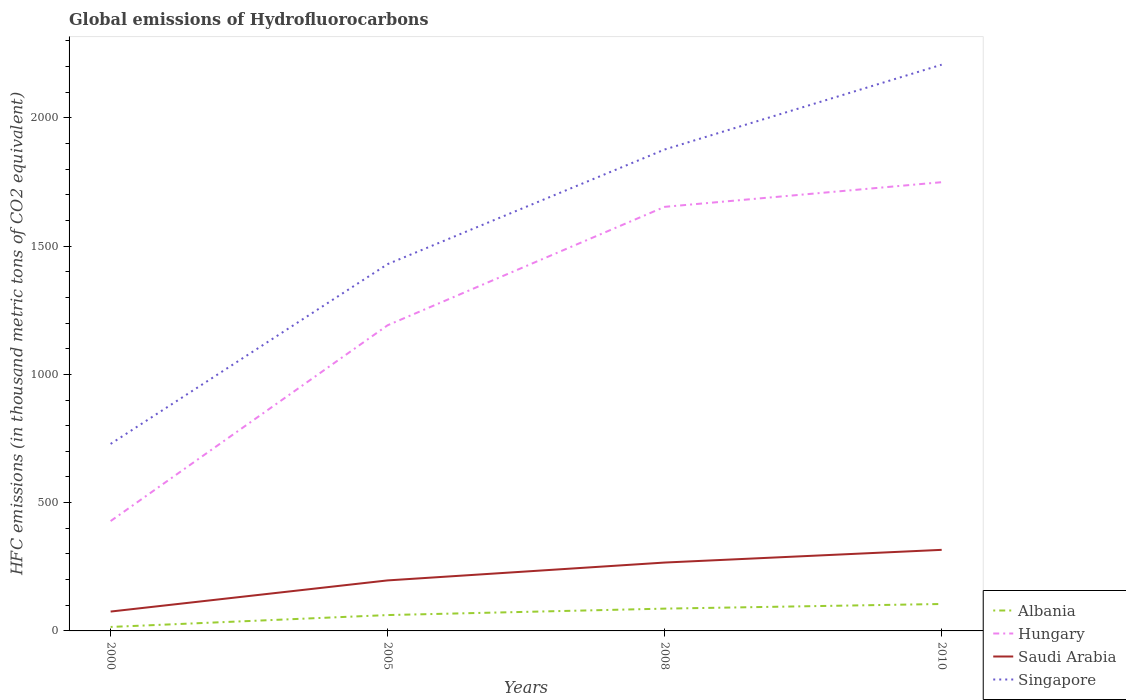Across all years, what is the maximum global emissions of Hydrofluorocarbons in Saudi Arabia?
Your response must be concise. 75.5. In which year was the global emissions of Hydrofluorocarbons in Hungary maximum?
Your answer should be very brief. 2000. What is the total global emissions of Hydrofluorocarbons in Saudi Arabia in the graph?
Provide a succinct answer. -49.5. What is the difference between the highest and the second highest global emissions of Hydrofluorocarbons in Albania?
Your response must be concise. 89.5. Is the global emissions of Hydrofluorocarbons in Hungary strictly greater than the global emissions of Hydrofluorocarbons in Saudi Arabia over the years?
Provide a short and direct response. No. How many years are there in the graph?
Your response must be concise. 4. Does the graph contain grids?
Give a very brief answer. No. How many legend labels are there?
Your response must be concise. 4. What is the title of the graph?
Your answer should be compact. Global emissions of Hydrofluorocarbons. Does "Botswana" appear as one of the legend labels in the graph?
Offer a very short reply. No. What is the label or title of the X-axis?
Provide a succinct answer. Years. What is the label or title of the Y-axis?
Make the answer very short. HFC emissions (in thousand metric tons of CO2 equivalent). What is the HFC emissions (in thousand metric tons of CO2 equivalent) of Hungary in 2000?
Offer a terse response. 428.2. What is the HFC emissions (in thousand metric tons of CO2 equivalent) of Saudi Arabia in 2000?
Offer a terse response. 75.5. What is the HFC emissions (in thousand metric tons of CO2 equivalent) of Singapore in 2000?
Provide a short and direct response. 728.9. What is the HFC emissions (in thousand metric tons of CO2 equivalent) in Albania in 2005?
Your answer should be compact. 61.8. What is the HFC emissions (in thousand metric tons of CO2 equivalent) in Hungary in 2005?
Provide a succinct answer. 1191.4. What is the HFC emissions (in thousand metric tons of CO2 equivalent) of Saudi Arabia in 2005?
Your answer should be compact. 196.9. What is the HFC emissions (in thousand metric tons of CO2 equivalent) in Singapore in 2005?
Offer a terse response. 1429.7. What is the HFC emissions (in thousand metric tons of CO2 equivalent) in Albania in 2008?
Provide a succinct answer. 86.9. What is the HFC emissions (in thousand metric tons of CO2 equivalent) of Hungary in 2008?
Keep it short and to the point. 1652.9. What is the HFC emissions (in thousand metric tons of CO2 equivalent) in Saudi Arabia in 2008?
Your response must be concise. 266.5. What is the HFC emissions (in thousand metric tons of CO2 equivalent) in Singapore in 2008?
Your answer should be compact. 1876.4. What is the HFC emissions (in thousand metric tons of CO2 equivalent) of Albania in 2010?
Your answer should be compact. 105. What is the HFC emissions (in thousand metric tons of CO2 equivalent) of Hungary in 2010?
Provide a succinct answer. 1749. What is the HFC emissions (in thousand metric tons of CO2 equivalent) of Saudi Arabia in 2010?
Provide a succinct answer. 316. What is the HFC emissions (in thousand metric tons of CO2 equivalent) in Singapore in 2010?
Ensure brevity in your answer.  2207. Across all years, what is the maximum HFC emissions (in thousand metric tons of CO2 equivalent) of Albania?
Offer a very short reply. 105. Across all years, what is the maximum HFC emissions (in thousand metric tons of CO2 equivalent) in Hungary?
Your answer should be very brief. 1749. Across all years, what is the maximum HFC emissions (in thousand metric tons of CO2 equivalent) of Saudi Arabia?
Your answer should be very brief. 316. Across all years, what is the maximum HFC emissions (in thousand metric tons of CO2 equivalent) of Singapore?
Make the answer very short. 2207. Across all years, what is the minimum HFC emissions (in thousand metric tons of CO2 equivalent) of Hungary?
Provide a short and direct response. 428.2. Across all years, what is the minimum HFC emissions (in thousand metric tons of CO2 equivalent) of Saudi Arabia?
Give a very brief answer. 75.5. Across all years, what is the minimum HFC emissions (in thousand metric tons of CO2 equivalent) of Singapore?
Give a very brief answer. 728.9. What is the total HFC emissions (in thousand metric tons of CO2 equivalent) in Albania in the graph?
Provide a short and direct response. 269.2. What is the total HFC emissions (in thousand metric tons of CO2 equivalent) in Hungary in the graph?
Make the answer very short. 5021.5. What is the total HFC emissions (in thousand metric tons of CO2 equivalent) of Saudi Arabia in the graph?
Offer a terse response. 854.9. What is the total HFC emissions (in thousand metric tons of CO2 equivalent) in Singapore in the graph?
Your answer should be compact. 6242. What is the difference between the HFC emissions (in thousand metric tons of CO2 equivalent) in Albania in 2000 and that in 2005?
Your answer should be compact. -46.3. What is the difference between the HFC emissions (in thousand metric tons of CO2 equivalent) of Hungary in 2000 and that in 2005?
Ensure brevity in your answer.  -763.2. What is the difference between the HFC emissions (in thousand metric tons of CO2 equivalent) of Saudi Arabia in 2000 and that in 2005?
Give a very brief answer. -121.4. What is the difference between the HFC emissions (in thousand metric tons of CO2 equivalent) in Singapore in 2000 and that in 2005?
Provide a short and direct response. -700.8. What is the difference between the HFC emissions (in thousand metric tons of CO2 equivalent) of Albania in 2000 and that in 2008?
Provide a succinct answer. -71.4. What is the difference between the HFC emissions (in thousand metric tons of CO2 equivalent) of Hungary in 2000 and that in 2008?
Give a very brief answer. -1224.7. What is the difference between the HFC emissions (in thousand metric tons of CO2 equivalent) of Saudi Arabia in 2000 and that in 2008?
Give a very brief answer. -191. What is the difference between the HFC emissions (in thousand metric tons of CO2 equivalent) of Singapore in 2000 and that in 2008?
Give a very brief answer. -1147.5. What is the difference between the HFC emissions (in thousand metric tons of CO2 equivalent) in Albania in 2000 and that in 2010?
Ensure brevity in your answer.  -89.5. What is the difference between the HFC emissions (in thousand metric tons of CO2 equivalent) of Hungary in 2000 and that in 2010?
Provide a succinct answer. -1320.8. What is the difference between the HFC emissions (in thousand metric tons of CO2 equivalent) of Saudi Arabia in 2000 and that in 2010?
Provide a short and direct response. -240.5. What is the difference between the HFC emissions (in thousand metric tons of CO2 equivalent) of Singapore in 2000 and that in 2010?
Provide a short and direct response. -1478.1. What is the difference between the HFC emissions (in thousand metric tons of CO2 equivalent) of Albania in 2005 and that in 2008?
Make the answer very short. -25.1. What is the difference between the HFC emissions (in thousand metric tons of CO2 equivalent) in Hungary in 2005 and that in 2008?
Provide a short and direct response. -461.5. What is the difference between the HFC emissions (in thousand metric tons of CO2 equivalent) in Saudi Arabia in 2005 and that in 2008?
Your answer should be very brief. -69.6. What is the difference between the HFC emissions (in thousand metric tons of CO2 equivalent) of Singapore in 2005 and that in 2008?
Keep it short and to the point. -446.7. What is the difference between the HFC emissions (in thousand metric tons of CO2 equivalent) in Albania in 2005 and that in 2010?
Make the answer very short. -43.2. What is the difference between the HFC emissions (in thousand metric tons of CO2 equivalent) of Hungary in 2005 and that in 2010?
Ensure brevity in your answer.  -557.6. What is the difference between the HFC emissions (in thousand metric tons of CO2 equivalent) of Saudi Arabia in 2005 and that in 2010?
Make the answer very short. -119.1. What is the difference between the HFC emissions (in thousand metric tons of CO2 equivalent) in Singapore in 2005 and that in 2010?
Provide a short and direct response. -777.3. What is the difference between the HFC emissions (in thousand metric tons of CO2 equivalent) of Albania in 2008 and that in 2010?
Your answer should be compact. -18.1. What is the difference between the HFC emissions (in thousand metric tons of CO2 equivalent) in Hungary in 2008 and that in 2010?
Offer a terse response. -96.1. What is the difference between the HFC emissions (in thousand metric tons of CO2 equivalent) in Saudi Arabia in 2008 and that in 2010?
Provide a succinct answer. -49.5. What is the difference between the HFC emissions (in thousand metric tons of CO2 equivalent) in Singapore in 2008 and that in 2010?
Give a very brief answer. -330.6. What is the difference between the HFC emissions (in thousand metric tons of CO2 equivalent) in Albania in 2000 and the HFC emissions (in thousand metric tons of CO2 equivalent) in Hungary in 2005?
Provide a short and direct response. -1175.9. What is the difference between the HFC emissions (in thousand metric tons of CO2 equivalent) of Albania in 2000 and the HFC emissions (in thousand metric tons of CO2 equivalent) of Saudi Arabia in 2005?
Provide a short and direct response. -181.4. What is the difference between the HFC emissions (in thousand metric tons of CO2 equivalent) of Albania in 2000 and the HFC emissions (in thousand metric tons of CO2 equivalent) of Singapore in 2005?
Provide a short and direct response. -1414.2. What is the difference between the HFC emissions (in thousand metric tons of CO2 equivalent) in Hungary in 2000 and the HFC emissions (in thousand metric tons of CO2 equivalent) in Saudi Arabia in 2005?
Keep it short and to the point. 231.3. What is the difference between the HFC emissions (in thousand metric tons of CO2 equivalent) of Hungary in 2000 and the HFC emissions (in thousand metric tons of CO2 equivalent) of Singapore in 2005?
Your answer should be compact. -1001.5. What is the difference between the HFC emissions (in thousand metric tons of CO2 equivalent) in Saudi Arabia in 2000 and the HFC emissions (in thousand metric tons of CO2 equivalent) in Singapore in 2005?
Give a very brief answer. -1354.2. What is the difference between the HFC emissions (in thousand metric tons of CO2 equivalent) in Albania in 2000 and the HFC emissions (in thousand metric tons of CO2 equivalent) in Hungary in 2008?
Make the answer very short. -1637.4. What is the difference between the HFC emissions (in thousand metric tons of CO2 equivalent) in Albania in 2000 and the HFC emissions (in thousand metric tons of CO2 equivalent) in Saudi Arabia in 2008?
Offer a terse response. -251. What is the difference between the HFC emissions (in thousand metric tons of CO2 equivalent) of Albania in 2000 and the HFC emissions (in thousand metric tons of CO2 equivalent) of Singapore in 2008?
Give a very brief answer. -1860.9. What is the difference between the HFC emissions (in thousand metric tons of CO2 equivalent) of Hungary in 2000 and the HFC emissions (in thousand metric tons of CO2 equivalent) of Saudi Arabia in 2008?
Provide a succinct answer. 161.7. What is the difference between the HFC emissions (in thousand metric tons of CO2 equivalent) of Hungary in 2000 and the HFC emissions (in thousand metric tons of CO2 equivalent) of Singapore in 2008?
Offer a very short reply. -1448.2. What is the difference between the HFC emissions (in thousand metric tons of CO2 equivalent) of Saudi Arabia in 2000 and the HFC emissions (in thousand metric tons of CO2 equivalent) of Singapore in 2008?
Give a very brief answer. -1800.9. What is the difference between the HFC emissions (in thousand metric tons of CO2 equivalent) in Albania in 2000 and the HFC emissions (in thousand metric tons of CO2 equivalent) in Hungary in 2010?
Ensure brevity in your answer.  -1733.5. What is the difference between the HFC emissions (in thousand metric tons of CO2 equivalent) of Albania in 2000 and the HFC emissions (in thousand metric tons of CO2 equivalent) of Saudi Arabia in 2010?
Provide a succinct answer. -300.5. What is the difference between the HFC emissions (in thousand metric tons of CO2 equivalent) of Albania in 2000 and the HFC emissions (in thousand metric tons of CO2 equivalent) of Singapore in 2010?
Ensure brevity in your answer.  -2191.5. What is the difference between the HFC emissions (in thousand metric tons of CO2 equivalent) of Hungary in 2000 and the HFC emissions (in thousand metric tons of CO2 equivalent) of Saudi Arabia in 2010?
Provide a short and direct response. 112.2. What is the difference between the HFC emissions (in thousand metric tons of CO2 equivalent) of Hungary in 2000 and the HFC emissions (in thousand metric tons of CO2 equivalent) of Singapore in 2010?
Offer a very short reply. -1778.8. What is the difference between the HFC emissions (in thousand metric tons of CO2 equivalent) of Saudi Arabia in 2000 and the HFC emissions (in thousand metric tons of CO2 equivalent) of Singapore in 2010?
Your answer should be very brief. -2131.5. What is the difference between the HFC emissions (in thousand metric tons of CO2 equivalent) of Albania in 2005 and the HFC emissions (in thousand metric tons of CO2 equivalent) of Hungary in 2008?
Offer a terse response. -1591.1. What is the difference between the HFC emissions (in thousand metric tons of CO2 equivalent) in Albania in 2005 and the HFC emissions (in thousand metric tons of CO2 equivalent) in Saudi Arabia in 2008?
Your answer should be very brief. -204.7. What is the difference between the HFC emissions (in thousand metric tons of CO2 equivalent) in Albania in 2005 and the HFC emissions (in thousand metric tons of CO2 equivalent) in Singapore in 2008?
Provide a short and direct response. -1814.6. What is the difference between the HFC emissions (in thousand metric tons of CO2 equivalent) in Hungary in 2005 and the HFC emissions (in thousand metric tons of CO2 equivalent) in Saudi Arabia in 2008?
Make the answer very short. 924.9. What is the difference between the HFC emissions (in thousand metric tons of CO2 equivalent) of Hungary in 2005 and the HFC emissions (in thousand metric tons of CO2 equivalent) of Singapore in 2008?
Provide a short and direct response. -685. What is the difference between the HFC emissions (in thousand metric tons of CO2 equivalent) of Saudi Arabia in 2005 and the HFC emissions (in thousand metric tons of CO2 equivalent) of Singapore in 2008?
Your answer should be very brief. -1679.5. What is the difference between the HFC emissions (in thousand metric tons of CO2 equivalent) in Albania in 2005 and the HFC emissions (in thousand metric tons of CO2 equivalent) in Hungary in 2010?
Your response must be concise. -1687.2. What is the difference between the HFC emissions (in thousand metric tons of CO2 equivalent) in Albania in 2005 and the HFC emissions (in thousand metric tons of CO2 equivalent) in Saudi Arabia in 2010?
Your answer should be compact. -254.2. What is the difference between the HFC emissions (in thousand metric tons of CO2 equivalent) of Albania in 2005 and the HFC emissions (in thousand metric tons of CO2 equivalent) of Singapore in 2010?
Keep it short and to the point. -2145.2. What is the difference between the HFC emissions (in thousand metric tons of CO2 equivalent) of Hungary in 2005 and the HFC emissions (in thousand metric tons of CO2 equivalent) of Saudi Arabia in 2010?
Give a very brief answer. 875.4. What is the difference between the HFC emissions (in thousand metric tons of CO2 equivalent) in Hungary in 2005 and the HFC emissions (in thousand metric tons of CO2 equivalent) in Singapore in 2010?
Provide a short and direct response. -1015.6. What is the difference between the HFC emissions (in thousand metric tons of CO2 equivalent) in Saudi Arabia in 2005 and the HFC emissions (in thousand metric tons of CO2 equivalent) in Singapore in 2010?
Provide a succinct answer. -2010.1. What is the difference between the HFC emissions (in thousand metric tons of CO2 equivalent) of Albania in 2008 and the HFC emissions (in thousand metric tons of CO2 equivalent) of Hungary in 2010?
Your response must be concise. -1662.1. What is the difference between the HFC emissions (in thousand metric tons of CO2 equivalent) in Albania in 2008 and the HFC emissions (in thousand metric tons of CO2 equivalent) in Saudi Arabia in 2010?
Offer a very short reply. -229.1. What is the difference between the HFC emissions (in thousand metric tons of CO2 equivalent) of Albania in 2008 and the HFC emissions (in thousand metric tons of CO2 equivalent) of Singapore in 2010?
Your response must be concise. -2120.1. What is the difference between the HFC emissions (in thousand metric tons of CO2 equivalent) in Hungary in 2008 and the HFC emissions (in thousand metric tons of CO2 equivalent) in Saudi Arabia in 2010?
Keep it short and to the point. 1336.9. What is the difference between the HFC emissions (in thousand metric tons of CO2 equivalent) of Hungary in 2008 and the HFC emissions (in thousand metric tons of CO2 equivalent) of Singapore in 2010?
Keep it short and to the point. -554.1. What is the difference between the HFC emissions (in thousand metric tons of CO2 equivalent) in Saudi Arabia in 2008 and the HFC emissions (in thousand metric tons of CO2 equivalent) in Singapore in 2010?
Your answer should be compact. -1940.5. What is the average HFC emissions (in thousand metric tons of CO2 equivalent) of Albania per year?
Ensure brevity in your answer.  67.3. What is the average HFC emissions (in thousand metric tons of CO2 equivalent) of Hungary per year?
Your response must be concise. 1255.38. What is the average HFC emissions (in thousand metric tons of CO2 equivalent) of Saudi Arabia per year?
Offer a terse response. 213.72. What is the average HFC emissions (in thousand metric tons of CO2 equivalent) in Singapore per year?
Provide a succinct answer. 1560.5. In the year 2000, what is the difference between the HFC emissions (in thousand metric tons of CO2 equivalent) of Albania and HFC emissions (in thousand metric tons of CO2 equivalent) of Hungary?
Give a very brief answer. -412.7. In the year 2000, what is the difference between the HFC emissions (in thousand metric tons of CO2 equivalent) of Albania and HFC emissions (in thousand metric tons of CO2 equivalent) of Saudi Arabia?
Give a very brief answer. -60. In the year 2000, what is the difference between the HFC emissions (in thousand metric tons of CO2 equivalent) of Albania and HFC emissions (in thousand metric tons of CO2 equivalent) of Singapore?
Your answer should be compact. -713.4. In the year 2000, what is the difference between the HFC emissions (in thousand metric tons of CO2 equivalent) of Hungary and HFC emissions (in thousand metric tons of CO2 equivalent) of Saudi Arabia?
Provide a short and direct response. 352.7. In the year 2000, what is the difference between the HFC emissions (in thousand metric tons of CO2 equivalent) in Hungary and HFC emissions (in thousand metric tons of CO2 equivalent) in Singapore?
Your answer should be compact. -300.7. In the year 2000, what is the difference between the HFC emissions (in thousand metric tons of CO2 equivalent) in Saudi Arabia and HFC emissions (in thousand metric tons of CO2 equivalent) in Singapore?
Provide a short and direct response. -653.4. In the year 2005, what is the difference between the HFC emissions (in thousand metric tons of CO2 equivalent) of Albania and HFC emissions (in thousand metric tons of CO2 equivalent) of Hungary?
Provide a short and direct response. -1129.6. In the year 2005, what is the difference between the HFC emissions (in thousand metric tons of CO2 equivalent) of Albania and HFC emissions (in thousand metric tons of CO2 equivalent) of Saudi Arabia?
Offer a very short reply. -135.1. In the year 2005, what is the difference between the HFC emissions (in thousand metric tons of CO2 equivalent) of Albania and HFC emissions (in thousand metric tons of CO2 equivalent) of Singapore?
Make the answer very short. -1367.9. In the year 2005, what is the difference between the HFC emissions (in thousand metric tons of CO2 equivalent) of Hungary and HFC emissions (in thousand metric tons of CO2 equivalent) of Saudi Arabia?
Ensure brevity in your answer.  994.5. In the year 2005, what is the difference between the HFC emissions (in thousand metric tons of CO2 equivalent) in Hungary and HFC emissions (in thousand metric tons of CO2 equivalent) in Singapore?
Offer a very short reply. -238.3. In the year 2005, what is the difference between the HFC emissions (in thousand metric tons of CO2 equivalent) in Saudi Arabia and HFC emissions (in thousand metric tons of CO2 equivalent) in Singapore?
Give a very brief answer. -1232.8. In the year 2008, what is the difference between the HFC emissions (in thousand metric tons of CO2 equivalent) of Albania and HFC emissions (in thousand metric tons of CO2 equivalent) of Hungary?
Provide a short and direct response. -1566. In the year 2008, what is the difference between the HFC emissions (in thousand metric tons of CO2 equivalent) in Albania and HFC emissions (in thousand metric tons of CO2 equivalent) in Saudi Arabia?
Your answer should be compact. -179.6. In the year 2008, what is the difference between the HFC emissions (in thousand metric tons of CO2 equivalent) in Albania and HFC emissions (in thousand metric tons of CO2 equivalent) in Singapore?
Your response must be concise. -1789.5. In the year 2008, what is the difference between the HFC emissions (in thousand metric tons of CO2 equivalent) of Hungary and HFC emissions (in thousand metric tons of CO2 equivalent) of Saudi Arabia?
Keep it short and to the point. 1386.4. In the year 2008, what is the difference between the HFC emissions (in thousand metric tons of CO2 equivalent) in Hungary and HFC emissions (in thousand metric tons of CO2 equivalent) in Singapore?
Your response must be concise. -223.5. In the year 2008, what is the difference between the HFC emissions (in thousand metric tons of CO2 equivalent) of Saudi Arabia and HFC emissions (in thousand metric tons of CO2 equivalent) of Singapore?
Your response must be concise. -1609.9. In the year 2010, what is the difference between the HFC emissions (in thousand metric tons of CO2 equivalent) of Albania and HFC emissions (in thousand metric tons of CO2 equivalent) of Hungary?
Provide a short and direct response. -1644. In the year 2010, what is the difference between the HFC emissions (in thousand metric tons of CO2 equivalent) of Albania and HFC emissions (in thousand metric tons of CO2 equivalent) of Saudi Arabia?
Ensure brevity in your answer.  -211. In the year 2010, what is the difference between the HFC emissions (in thousand metric tons of CO2 equivalent) of Albania and HFC emissions (in thousand metric tons of CO2 equivalent) of Singapore?
Give a very brief answer. -2102. In the year 2010, what is the difference between the HFC emissions (in thousand metric tons of CO2 equivalent) in Hungary and HFC emissions (in thousand metric tons of CO2 equivalent) in Saudi Arabia?
Offer a very short reply. 1433. In the year 2010, what is the difference between the HFC emissions (in thousand metric tons of CO2 equivalent) in Hungary and HFC emissions (in thousand metric tons of CO2 equivalent) in Singapore?
Your answer should be very brief. -458. In the year 2010, what is the difference between the HFC emissions (in thousand metric tons of CO2 equivalent) of Saudi Arabia and HFC emissions (in thousand metric tons of CO2 equivalent) of Singapore?
Offer a very short reply. -1891. What is the ratio of the HFC emissions (in thousand metric tons of CO2 equivalent) of Albania in 2000 to that in 2005?
Give a very brief answer. 0.25. What is the ratio of the HFC emissions (in thousand metric tons of CO2 equivalent) in Hungary in 2000 to that in 2005?
Your response must be concise. 0.36. What is the ratio of the HFC emissions (in thousand metric tons of CO2 equivalent) of Saudi Arabia in 2000 to that in 2005?
Your response must be concise. 0.38. What is the ratio of the HFC emissions (in thousand metric tons of CO2 equivalent) in Singapore in 2000 to that in 2005?
Make the answer very short. 0.51. What is the ratio of the HFC emissions (in thousand metric tons of CO2 equivalent) in Albania in 2000 to that in 2008?
Offer a terse response. 0.18. What is the ratio of the HFC emissions (in thousand metric tons of CO2 equivalent) of Hungary in 2000 to that in 2008?
Offer a terse response. 0.26. What is the ratio of the HFC emissions (in thousand metric tons of CO2 equivalent) of Saudi Arabia in 2000 to that in 2008?
Keep it short and to the point. 0.28. What is the ratio of the HFC emissions (in thousand metric tons of CO2 equivalent) of Singapore in 2000 to that in 2008?
Your response must be concise. 0.39. What is the ratio of the HFC emissions (in thousand metric tons of CO2 equivalent) of Albania in 2000 to that in 2010?
Offer a terse response. 0.15. What is the ratio of the HFC emissions (in thousand metric tons of CO2 equivalent) in Hungary in 2000 to that in 2010?
Provide a short and direct response. 0.24. What is the ratio of the HFC emissions (in thousand metric tons of CO2 equivalent) in Saudi Arabia in 2000 to that in 2010?
Make the answer very short. 0.24. What is the ratio of the HFC emissions (in thousand metric tons of CO2 equivalent) in Singapore in 2000 to that in 2010?
Offer a terse response. 0.33. What is the ratio of the HFC emissions (in thousand metric tons of CO2 equivalent) of Albania in 2005 to that in 2008?
Provide a short and direct response. 0.71. What is the ratio of the HFC emissions (in thousand metric tons of CO2 equivalent) of Hungary in 2005 to that in 2008?
Offer a terse response. 0.72. What is the ratio of the HFC emissions (in thousand metric tons of CO2 equivalent) of Saudi Arabia in 2005 to that in 2008?
Give a very brief answer. 0.74. What is the ratio of the HFC emissions (in thousand metric tons of CO2 equivalent) of Singapore in 2005 to that in 2008?
Your response must be concise. 0.76. What is the ratio of the HFC emissions (in thousand metric tons of CO2 equivalent) of Albania in 2005 to that in 2010?
Your answer should be compact. 0.59. What is the ratio of the HFC emissions (in thousand metric tons of CO2 equivalent) of Hungary in 2005 to that in 2010?
Offer a very short reply. 0.68. What is the ratio of the HFC emissions (in thousand metric tons of CO2 equivalent) in Saudi Arabia in 2005 to that in 2010?
Your answer should be very brief. 0.62. What is the ratio of the HFC emissions (in thousand metric tons of CO2 equivalent) of Singapore in 2005 to that in 2010?
Your answer should be very brief. 0.65. What is the ratio of the HFC emissions (in thousand metric tons of CO2 equivalent) in Albania in 2008 to that in 2010?
Offer a very short reply. 0.83. What is the ratio of the HFC emissions (in thousand metric tons of CO2 equivalent) of Hungary in 2008 to that in 2010?
Make the answer very short. 0.95. What is the ratio of the HFC emissions (in thousand metric tons of CO2 equivalent) in Saudi Arabia in 2008 to that in 2010?
Offer a terse response. 0.84. What is the ratio of the HFC emissions (in thousand metric tons of CO2 equivalent) of Singapore in 2008 to that in 2010?
Your response must be concise. 0.85. What is the difference between the highest and the second highest HFC emissions (in thousand metric tons of CO2 equivalent) in Albania?
Keep it short and to the point. 18.1. What is the difference between the highest and the second highest HFC emissions (in thousand metric tons of CO2 equivalent) in Hungary?
Give a very brief answer. 96.1. What is the difference between the highest and the second highest HFC emissions (in thousand metric tons of CO2 equivalent) in Saudi Arabia?
Make the answer very short. 49.5. What is the difference between the highest and the second highest HFC emissions (in thousand metric tons of CO2 equivalent) of Singapore?
Make the answer very short. 330.6. What is the difference between the highest and the lowest HFC emissions (in thousand metric tons of CO2 equivalent) of Albania?
Your answer should be very brief. 89.5. What is the difference between the highest and the lowest HFC emissions (in thousand metric tons of CO2 equivalent) in Hungary?
Your answer should be very brief. 1320.8. What is the difference between the highest and the lowest HFC emissions (in thousand metric tons of CO2 equivalent) in Saudi Arabia?
Your response must be concise. 240.5. What is the difference between the highest and the lowest HFC emissions (in thousand metric tons of CO2 equivalent) in Singapore?
Provide a succinct answer. 1478.1. 